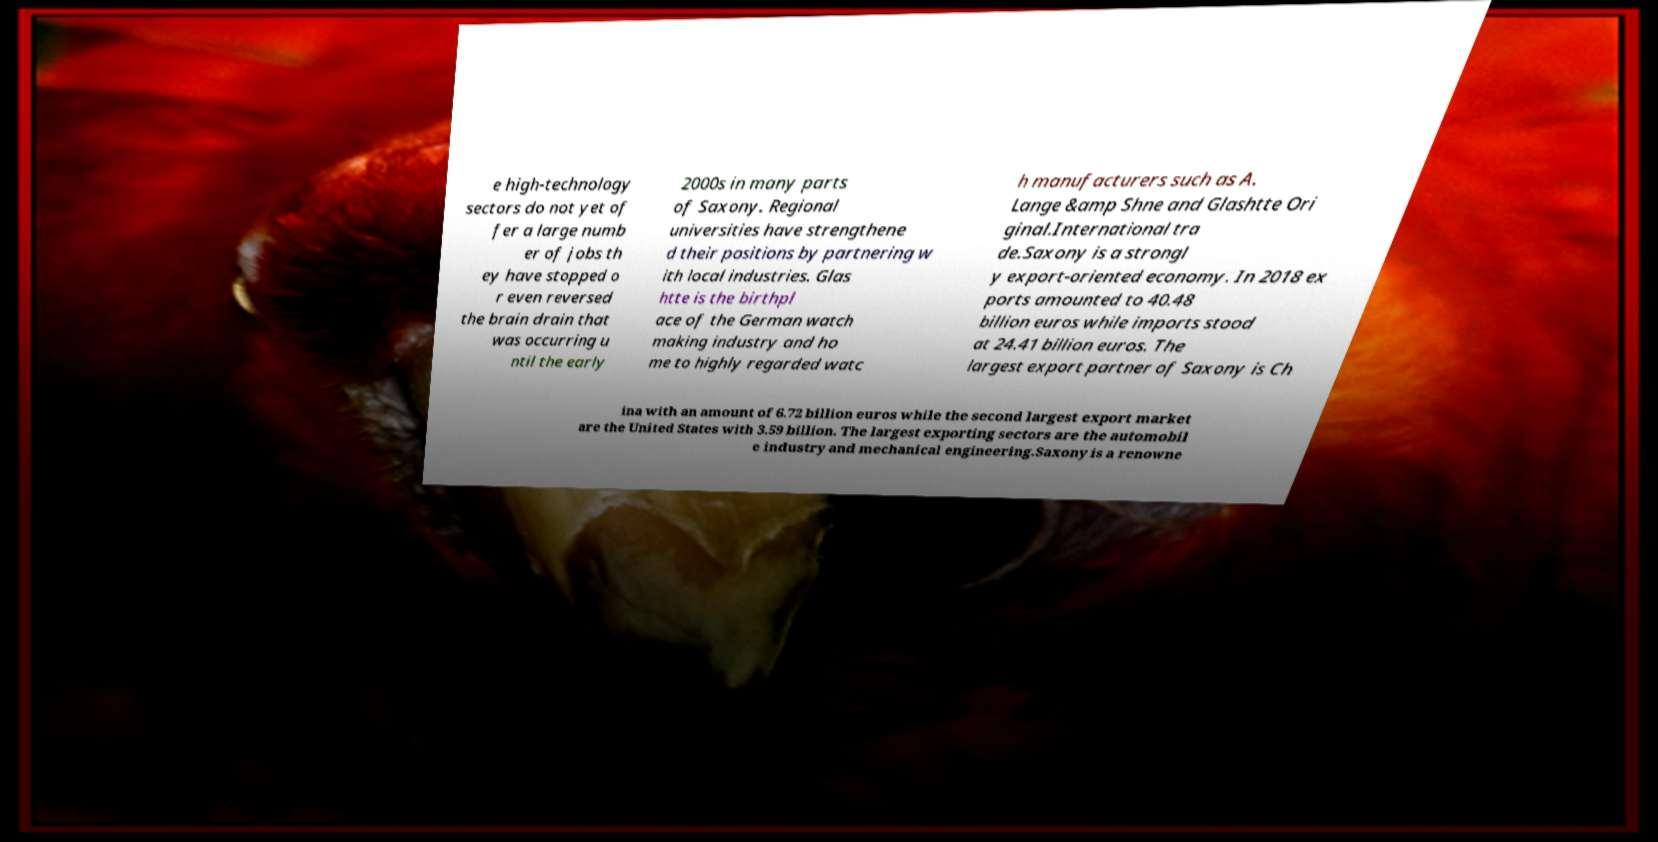What messages or text are displayed in this image? I need them in a readable, typed format. e high-technology sectors do not yet of fer a large numb er of jobs th ey have stopped o r even reversed the brain drain that was occurring u ntil the early 2000s in many parts of Saxony. Regional universities have strengthene d their positions by partnering w ith local industries. Glas htte is the birthpl ace of the German watch making industry and ho me to highly regarded watc h manufacturers such as A. Lange &amp Shne and Glashtte Ori ginal.International tra de.Saxony is a strongl y export-oriented economy. In 2018 ex ports amounted to 40.48 billion euros while imports stood at 24.41 billion euros. The largest export partner of Saxony is Ch ina with an amount of 6.72 billion euros while the second largest export market are the United States with 3.59 billion. The largest exporting sectors are the automobil e industry and mechanical engineering.Saxony is a renowne 